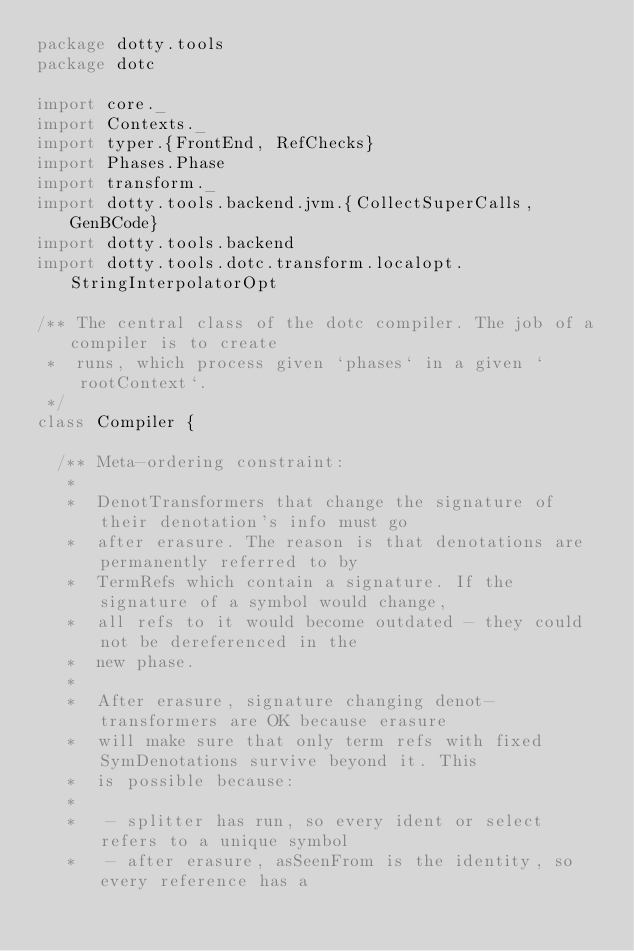Convert code to text. <code><loc_0><loc_0><loc_500><loc_500><_Scala_>package dotty.tools
package dotc

import core._
import Contexts._
import typer.{FrontEnd, RefChecks}
import Phases.Phase
import transform._
import dotty.tools.backend.jvm.{CollectSuperCalls, GenBCode}
import dotty.tools.backend
import dotty.tools.dotc.transform.localopt.StringInterpolatorOpt

/** The central class of the dotc compiler. The job of a compiler is to create
 *  runs, which process given `phases` in a given `rootContext`.
 */
class Compiler {

  /** Meta-ordering constraint:
   *
   *  DenotTransformers that change the signature of their denotation's info must go
   *  after erasure. The reason is that denotations are permanently referred to by
   *  TermRefs which contain a signature. If the signature of a symbol would change,
   *  all refs to it would become outdated - they could not be dereferenced in the
   *  new phase.
   *
   *  After erasure, signature changing denot-transformers are OK because erasure
   *  will make sure that only term refs with fixed SymDenotations survive beyond it. This
   *  is possible because:
   *
   *   - splitter has run, so every ident or select refers to a unique symbol
   *   - after erasure, asSeenFrom is the identity, so every reference has a</code> 